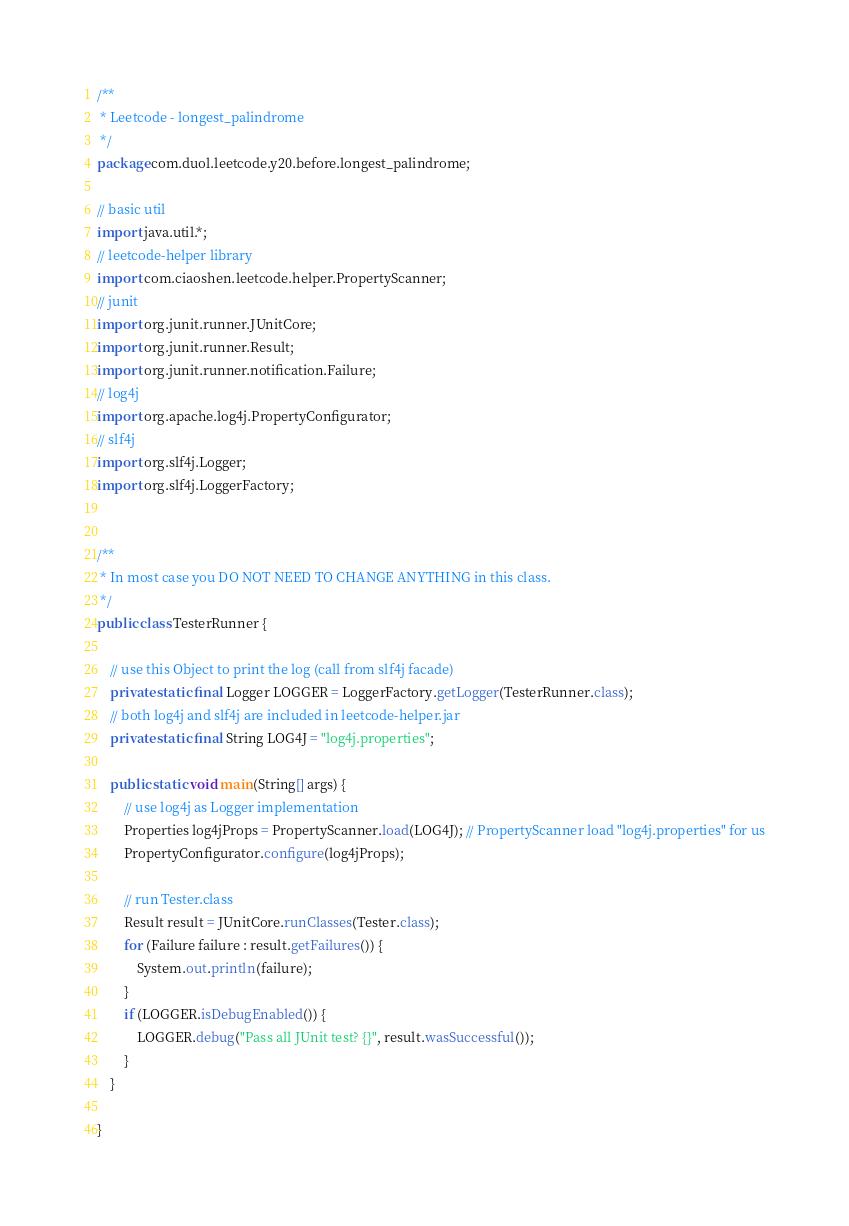Convert code to text. <code><loc_0><loc_0><loc_500><loc_500><_Java_>/**
 * Leetcode - longest_palindrome
 */
package com.duol.leetcode.y20.before.longest_palindrome;

// basic util
import java.util.*;
// leetcode-helper library
import com.ciaoshen.leetcode.helper.PropertyScanner;
// junit 
import org.junit.runner.JUnitCore;
import org.junit.runner.Result;
import org.junit.runner.notification.Failure;
// log4j
import org.apache.log4j.PropertyConfigurator;
// slf4j
import org.slf4j.Logger;
import org.slf4j.LoggerFactory;


/**
 * In most case you DO NOT NEED TO CHANGE ANYTHING in this class.
 */
public class TesterRunner {

    // use this Object to print the log (call from slf4j facade)
    private static final Logger LOGGER = LoggerFactory.getLogger(TesterRunner.class);
    // both log4j and slf4j are included in leetcode-helper.jar
    private static final String LOG4J = "log4j.properties";

    public static void main(String[] args) {
        // use log4j as Logger implementation
        Properties log4jProps = PropertyScanner.load(LOG4J); // PropertyScanner load "log4j.properties" for us
        PropertyConfigurator.configure(log4jProps);

        // run Tester.class
        Result result = JUnitCore.runClasses(Tester.class);
        for (Failure failure : result.getFailures()) {
            System.out.println(failure);
        }
        if (LOGGER.isDebugEnabled()) {
            LOGGER.debug("Pass all JUnit test? {}", result.wasSuccessful());
        }
    }

}
</code> 